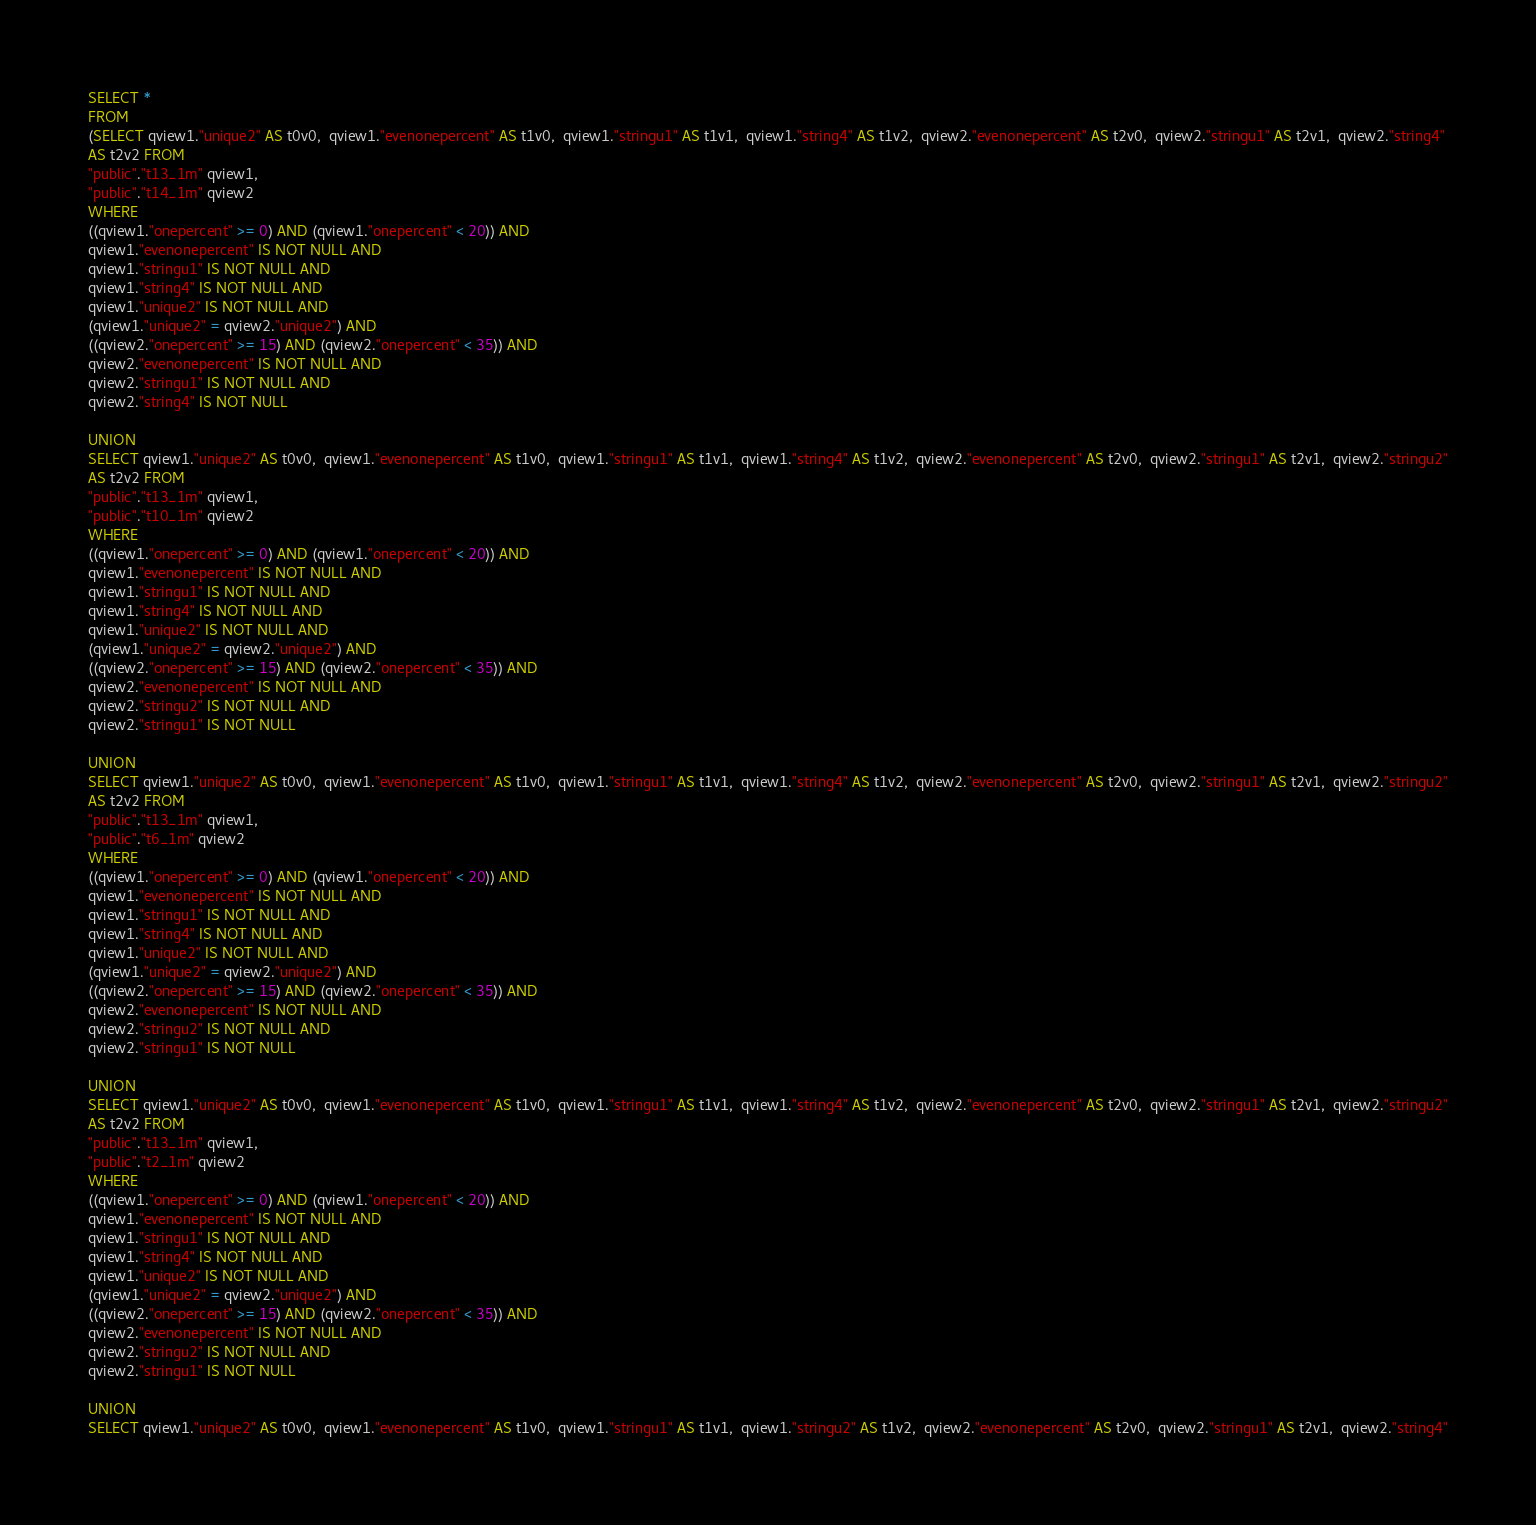<code> <loc_0><loc_0><loc_500><loc_500><_SQL_>SELECT *
FROM
(SELECT qview1."unique2" AS t0v0,  qview1."evenonepercent" AS t1v0,  qview1."stringu1" AS t1v1,  qview1."string4" AS t1v2,  qview2."evenonepercent" AS t2v0,  qview2."stringu1" AS t2v1,  qview2."string4"
AS t2v2 FROM
"public"."t13_1m" qview1,
"public"."t14_1m" qview2
WHERE
((qview1."onepercent" >= 0) AND (qview1."onepercent" < 20)) AND
qview1."evenonepercent" IS NOT NULL AND
qview1."stringu1" IS NOT NULL AND
qview1."string4" IS NOT NULL AND
qview1."unique2" IS NOT NULL AND
(qview1."unique2" = qview2."unique2") AND
((qview2."onepercent" >= 15) AND (qview2."onepercent" < 35)) AND
qview2."evenonepercent" IS NOT NULL AND
qview2."stringu1" IS NOT NULL AND
qview2."string4" IS NOT NULL

UNION
SELECT qview1."unique2" AS t0v0,  qview1."evenonepercent" AS t1v0,  qview1."stringu1" AS t1v1,  qview1."string4" AS t1v2,  qview2."evenonepercent" AS t2v0,  qview2."stringu1" AS t2v1,  qview2."stringu2"
AS t2v2 FROM
"public"."t13_1m" qview1,
"public"."t10_1m" qview2
WHERE
((qview1."onepercent" >= 0) AND (qview1."onepercent" < 20)) AND
qview1."evenonepercent" IS NOT NULL AND
qview1."stringu1" IS NOT NULL AND
qview1."string4" IS NOT NULL AND
qview1."unique2" IS NOT NULL AND
(qview1."unique2" = qview2."unique2") AND
((qview2."onepercent" >= 15) AND (qview2."onepercent" < 35)) AND
qview2."evenonepercent" IS NOT NULL AND
qview2."stringu2" IS NOT NULL AND
qview2."stringu1" IS NOT NULL

UNION
SELECT qview1."unique2" AS t0v0,  qview1."evenonepercent" AS t1v0,  qview1."stringu1" AS t1v1,  qview1."string4" AS t1v2,  qview2."evenonepercent" AS t2v0,  qview2."stringu1" AS t2v1,  qview2."stringu2"
AS t2v2 FROM
"public"."t13_1m" qview1,
"public"."t6_1m" qview2
WHERE
((qview1."onepercent" >= 0) AND (qview1."onepercent" < 20)) AND
qview1."evenonepercent" IS NOT NULL AND
qview1."stringu1" IS NOT NULL AND
qview1."string4" IS NOT NULL AND
qview1."unique2" IS NOT NULL AND
(qview1."unique2" = qview2."unique2") AND
((qview2."onepercent" >= 15) AND (qview2."onepercent" < 35)) AND
qview2."evenonepercent" IS NOT NULL AND
qview2."stringu2" IS NOT NULL AND
qview2."stringu1" IS NOT NULL

UNION
SELECT qview1."unique2" AS t0v0,  qview1."evenonepercent" AS t1v0,  qview1."stringu1" AS t1v1,  qview1."string4" AS t1v2,  qview2."evenonepercent" AS t2v0,  qview2."stringu1" AS t2v1,  qview2."stringu2"
AS t2v2 FROM
"public"."t13_1m" qview1,
"public"."t2_1m" qview2
WHERE
((qview1."onepercent" >= 0) AND (qview1."onepercent" < 20)) AND
qview1."evenonepercent" IS NOT NULL AND
qview1."stringu1" IS NOT NULL AND
qview1."string4" IS NOT NULL AND
qview1."unique2" IS NOT NULL AND
(qview1."unique2" = qview2."unique2") AND
((qview2."onepercent" >= 15) AND (qview2."onepercent" < 35)) AND
qview2."evenonepercent" IS NOT NULL AND
qview2."stringu2" IS NOT NULL AND
qview2."stringu1" IS NOT NULL

UNION
SELECT qview1."unique2" AS t0v0,  qview1."evenonepercent" AS t1v0,  qview1."stringu1" AS t1v1,  qview1."stringu2" AS t1v2,  qview2."evenonepercent" AS t2v0,  qview2."stringu1" AS t2v1,  qview2."string4"</code> 